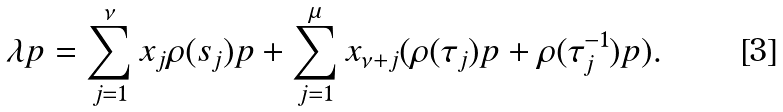<formula> <loc_0><loc_0><loc_500><loc_500>\lambda p = \sum _ { j = 1 } ^ { \nu } x _ { j } \rho ( s _ { j } ) p + \sum _ { j = 1 } ^ { \mu } x _ { \nu + j } ( \rho ( \tau _ { j } ) p + \rho ( \tau _ { j } ^ { - 1 } ) p ) .</formula> 